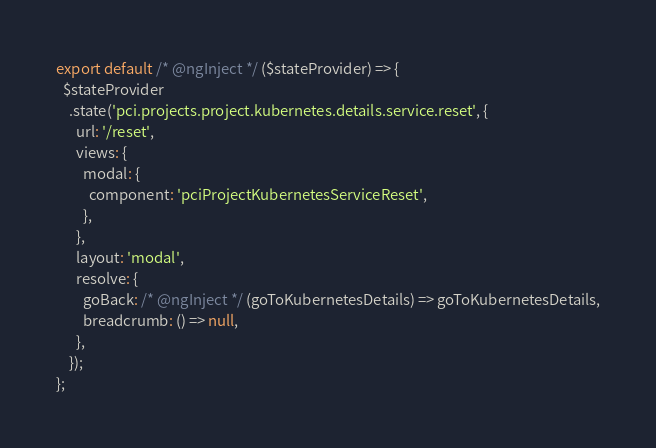<code> <loc_0><loc_0><loc_500><loc_500><_JavaScript_>export default /* @ngInject */ ($stateProvider) => {
  $stateProvider
    .state('pci.projects.project.kubernetes.details.service.reset', {
      url: '/reset',
      views: {
        modal: {
          component: 'pciProjectKubernetesServiceReset',
        },
      },
      layout: 'modal',
      resolve: {
        goBack: /* @ngInject */ (goToKubernetesDetails) => goToKubernetesDetails,
        breadcrumb: () => null,
      },
    });
};
</code> 